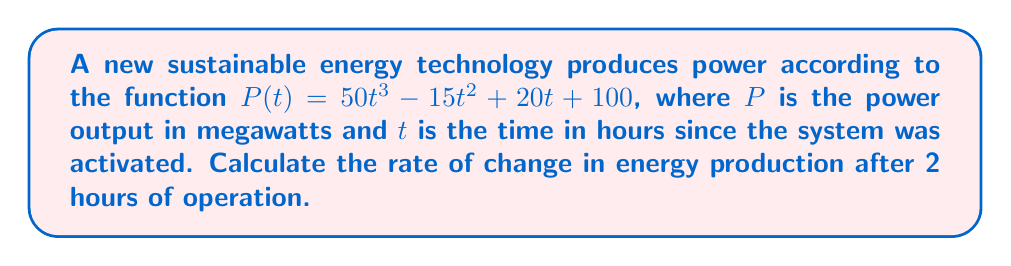Give your solution to this math problem. To find the rate of change in energy production, we need to calculate the derivative of the power function $P(t)$ and then evaluate it at $t = 2$ hours.

Step 1: Calculate the derivative of $P(t)$
$$\frac{d}{dt}P(t) = \frac{d}{dt}(50t^3 - 15t^2 + 20t + 100)$$
$$P'(t) = 150t^2 - 30t + 20$$

Step 2: Evaluate $P'(t)$ at $t = 2$
$$P'(2) = 150(2)^2 - 30(2) + 20$$
$$P'(2) = 150(4) - 60 + 20$$
$$P'(2) = 600 - 60 + 20$$
$$P'(2) = 560$$

The rate of change in energy production after 2 hours is 560 megawatts per hour.
Answer: 560 MW/h 